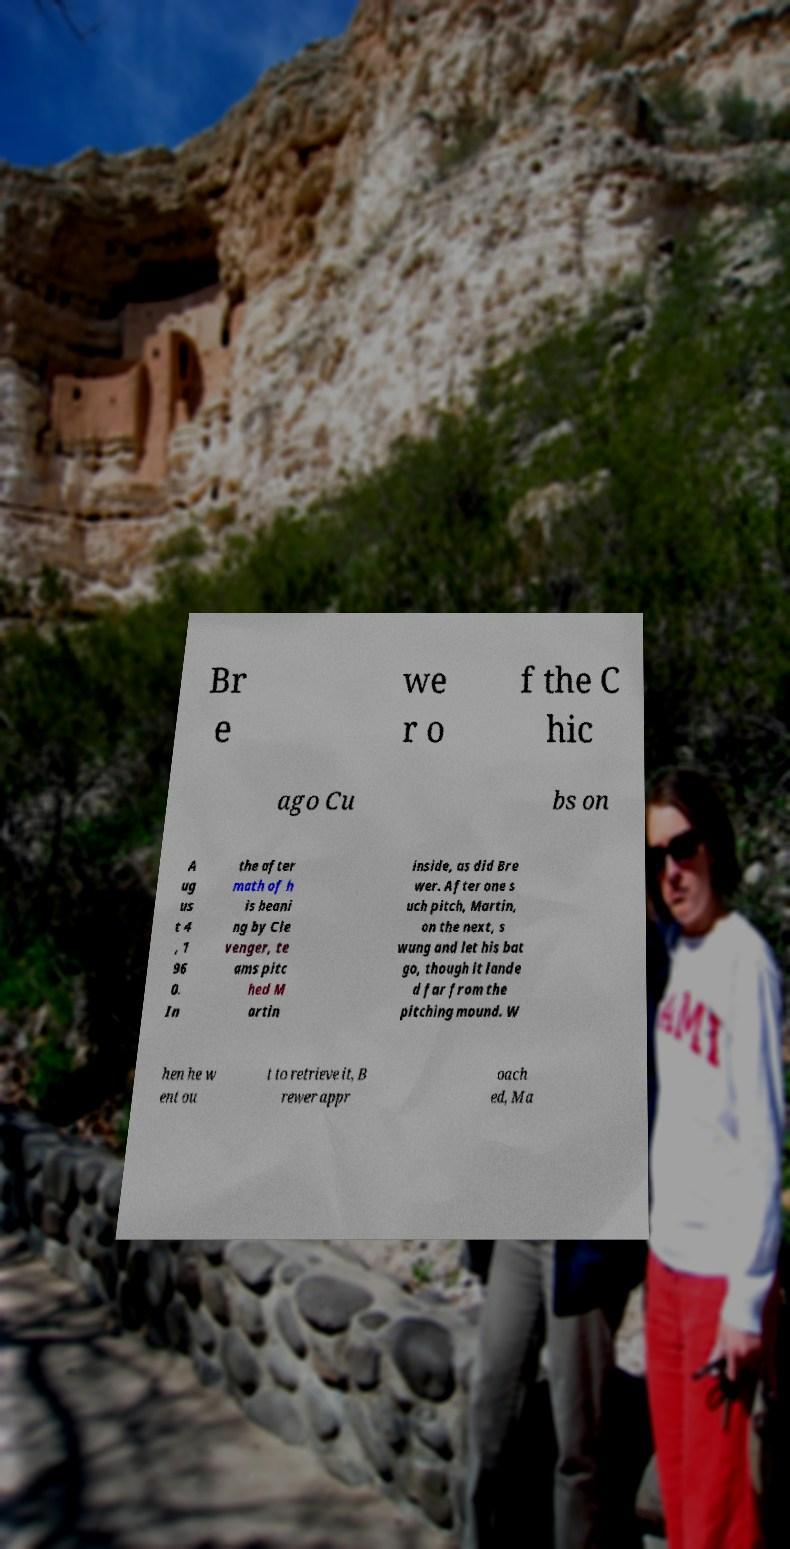Can you accurately transcribe the text from the provided image for me? Br e we r o f the C hic ago Cu bs on A ug us t 4 , 1 96 0. In the after math of h is beani ng by Cle venger, te ams pitc hed M artin inside, as did Bre wer. After one s uch pitch, Martin, on the next, s wung and let his bat go, though it lande d far from the pitching mound. W hen he w ent ou t to retrieve it, B rewer appr oach ed, Ma 